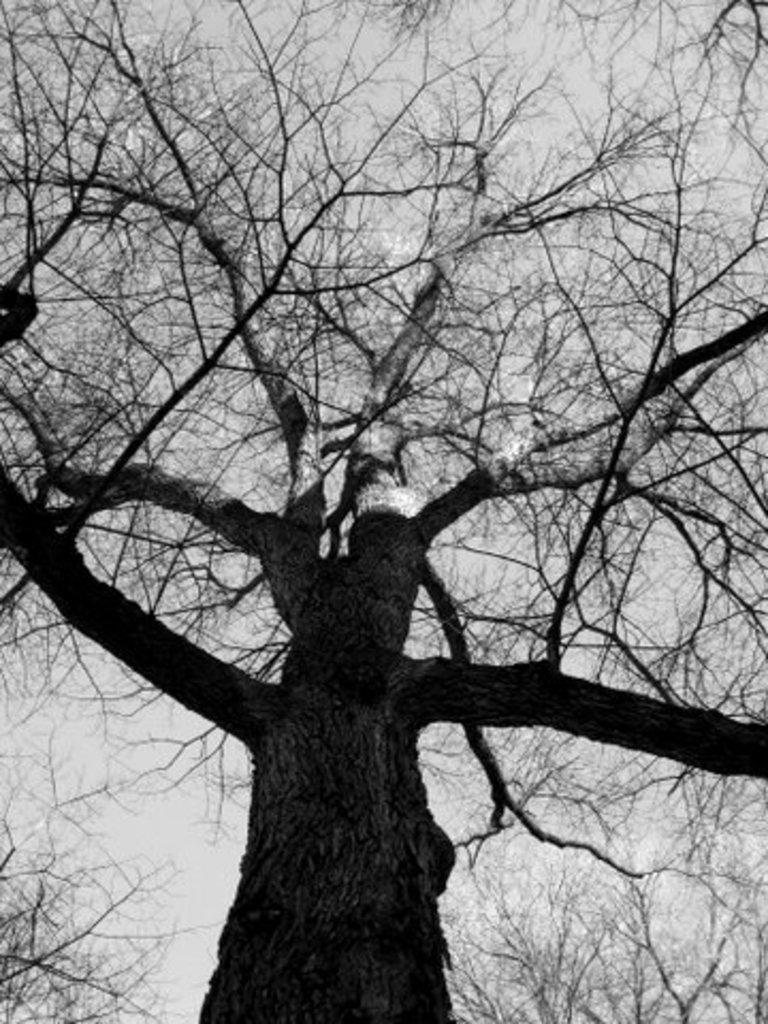What is located in the foreground of the image? There is a tree without leaves in the foreground of the image. What is visible at the top of the image? The sky is visible at the top of the image. What type of food is the tree eating in the image? Trees do not eat food, so this question is not applicable to the image. 